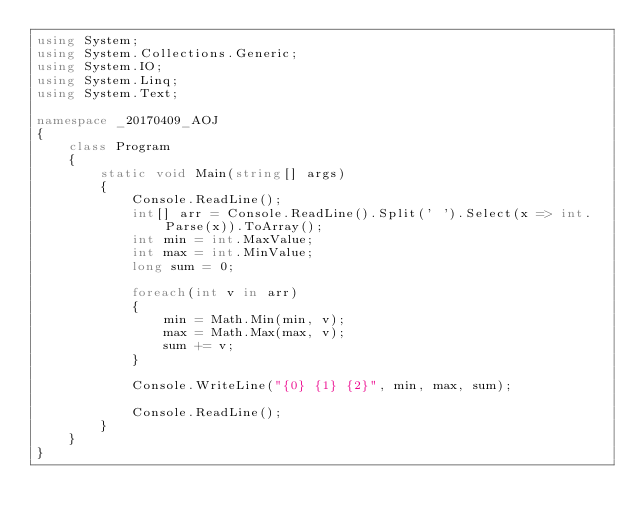Convert code to text. <code><loc_0><loc_0><loc_500><loc_500><_C#_>using System;
using System.Collections.Generic;
using System.IO;
using System.Linq;
using System.Text;

namespace _20170409_AOJ
{
    class Program
    {
        static void Main(string[] args)
        {
            Console.ReadLine();
            int[] arr = Console.ReadLine().Split(' ').Select(x => int.Parse(x)).ToArray();
            int min = int.MaxValue;
            int max = int.MinValue;
            long sum = 0;
            
            foreach(int v in arr)
            {
                min = Math.Min(min, v);
                max = Math.Max(max, v);
                sum += v;
            }

            Console.WriteLine("{0} {1} {2}", min, max, sum);

            Console.ReadLine();
        }
    }
}</code> 